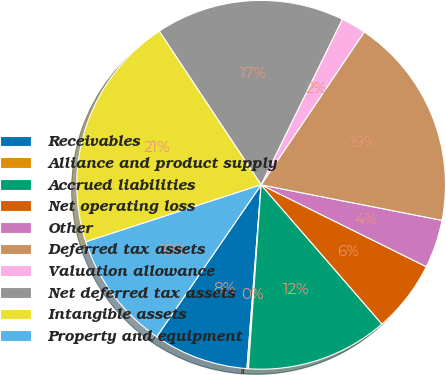Convert chart to OTSL. <chart><loc_0><loc_0><loc_500><loc_500><pie_chart><fcel>Receivables<fcel>Alliance and product supply<fcel>Accrued liabilities<fcel>Net operating loss<fcel>Other<fcel>Deferred tax assets<fcel>Valuation allowance<fcel>Net deferred tax assets<fcel>Intangible assets<fcel>Property and equipment<nl><fcel>8.36%<fcel>0.13%<fcel>12.47%<fcel>6.3%<fcel>4.24%<fcel>18.64%<fcel>2.19%<fcel>16.58%<fcel>20.69%<fcel>10.41%<nl></chart> 